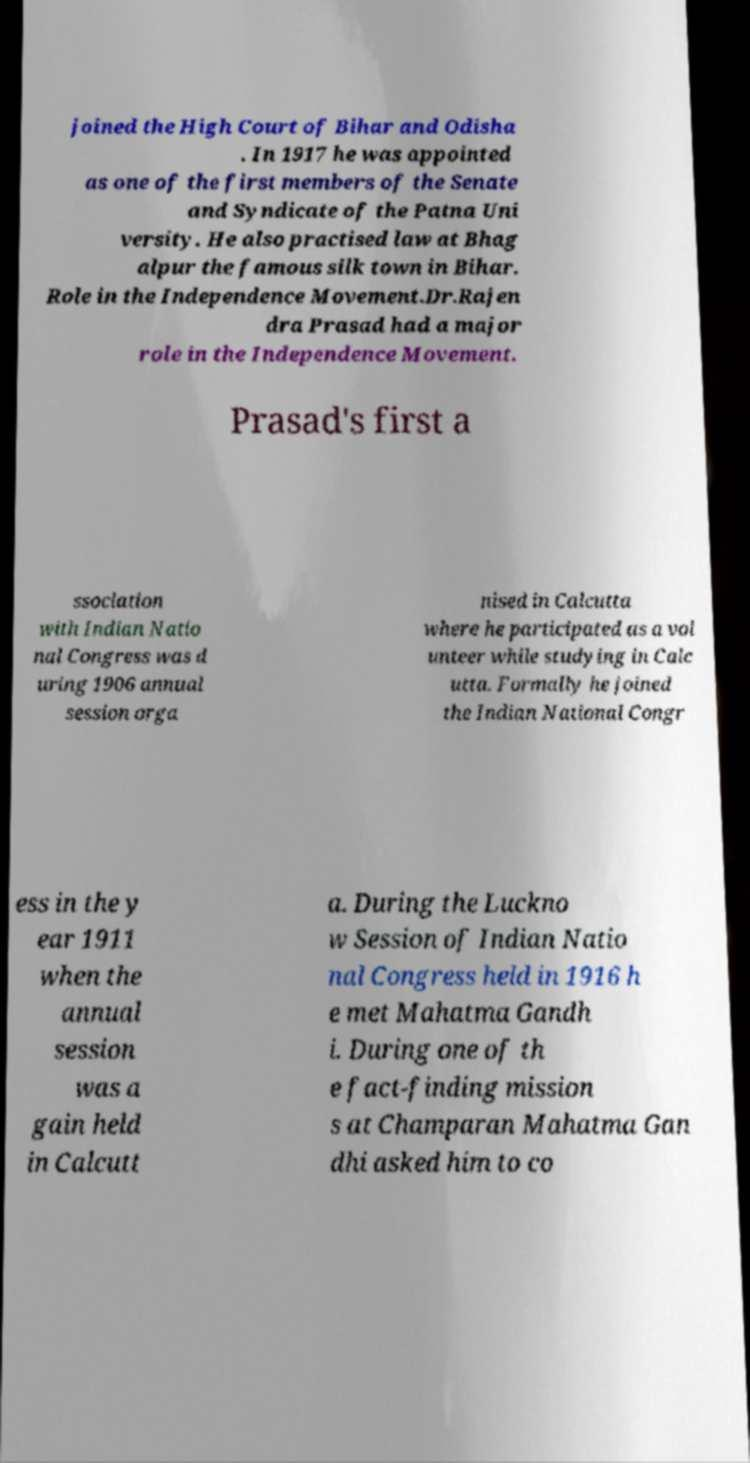Could you assist in decoding the text presented in this image and type it out clearly? joined the High Court of Bihar and Odisha . In 1917 he was appointed as one of the first members of the Senate and Syndicate of the Patna Uni versity. He also practised law at Bhag alpur the famous silk town in Bihar. Role in the Independence Movement.Dr.Rajen dra Prasad had a major role in the Independence Movement. Prasad's first a ssociation with Indian Natio nal Congress was d uring 1906 annual session orga nised in Calcutta where he participated as a vol unteer while studying in Calc utta. Formally he joined the Indian National Congr ess in the y ear 1911 when the annual session was a gain held in Calcutt a. During the Luckno w Session of Indian Natio nal Congress held in 1916 h e met Mahatma Gandh i. During one of th e fact-finding mission s at Champaran Mahatma Gan dhi asked him to co 